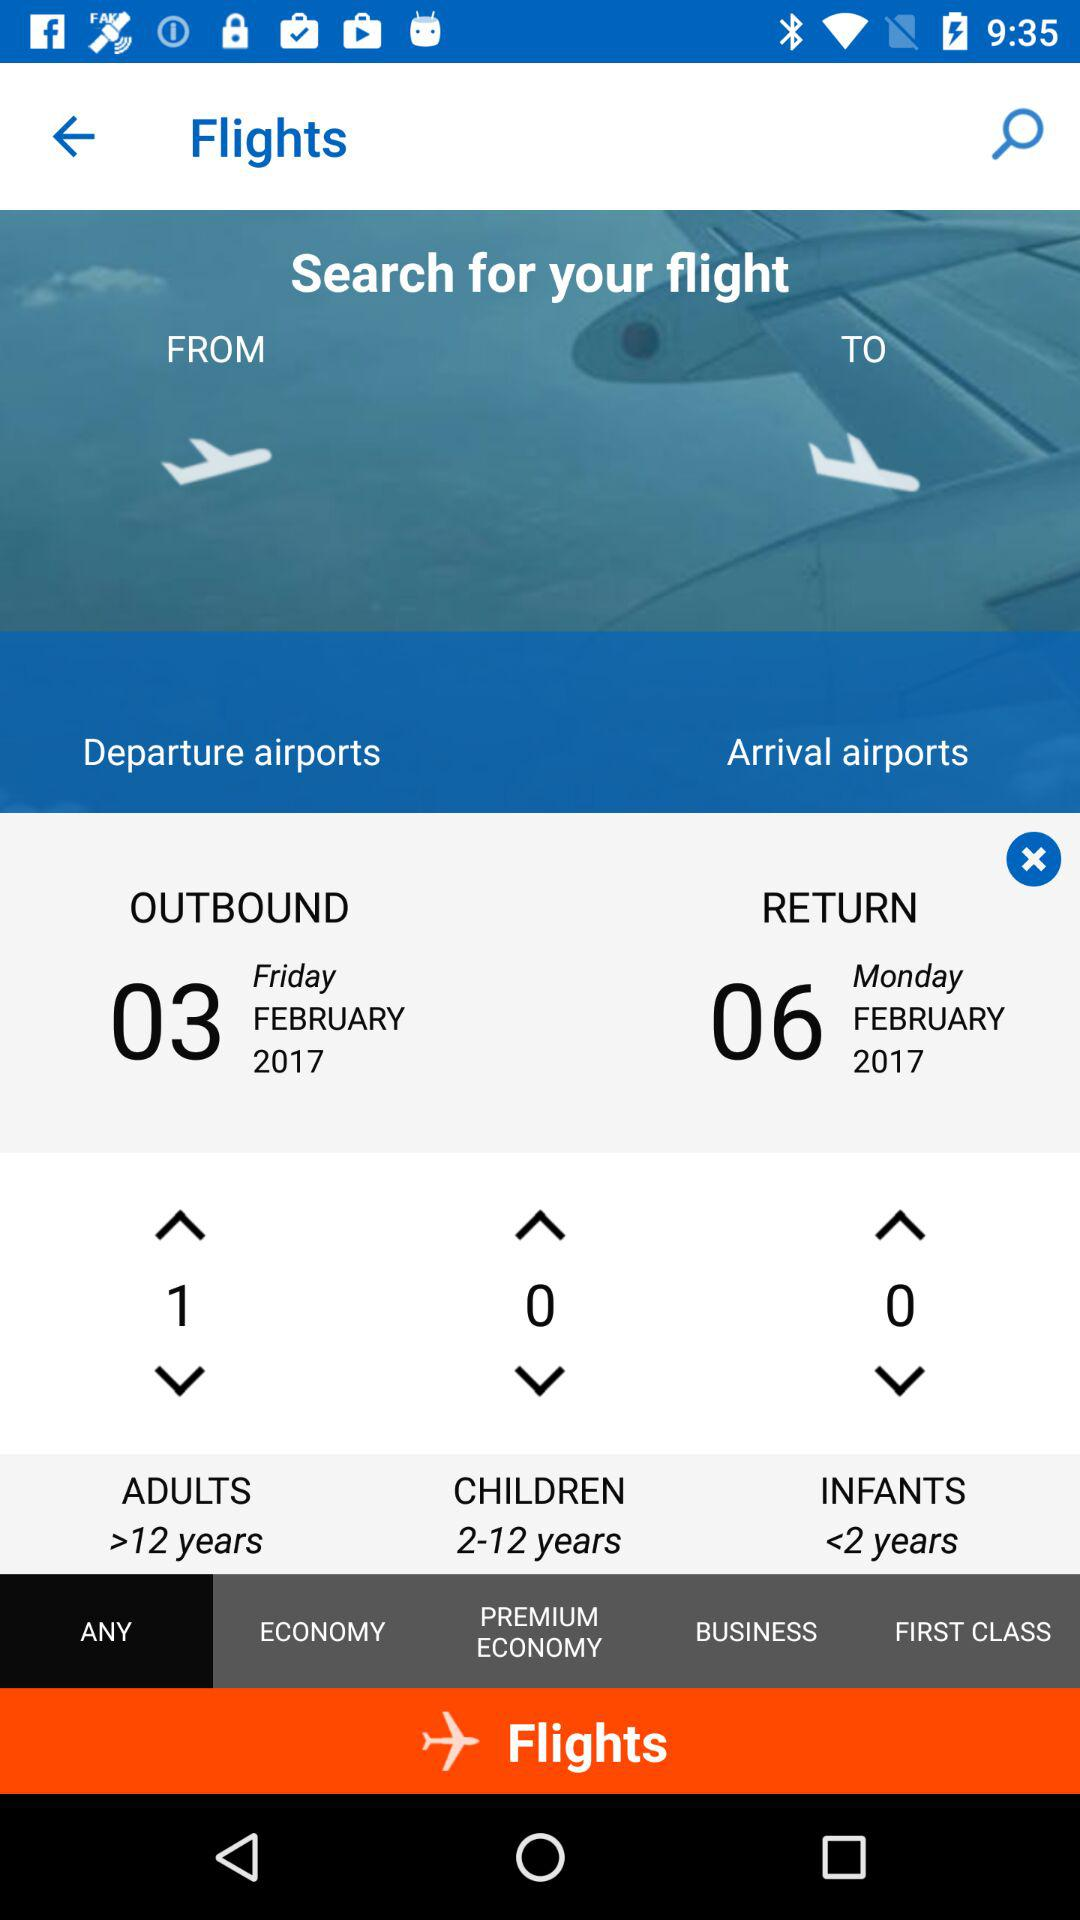What is the return date? The return date is Monday, February 6, 2017. 